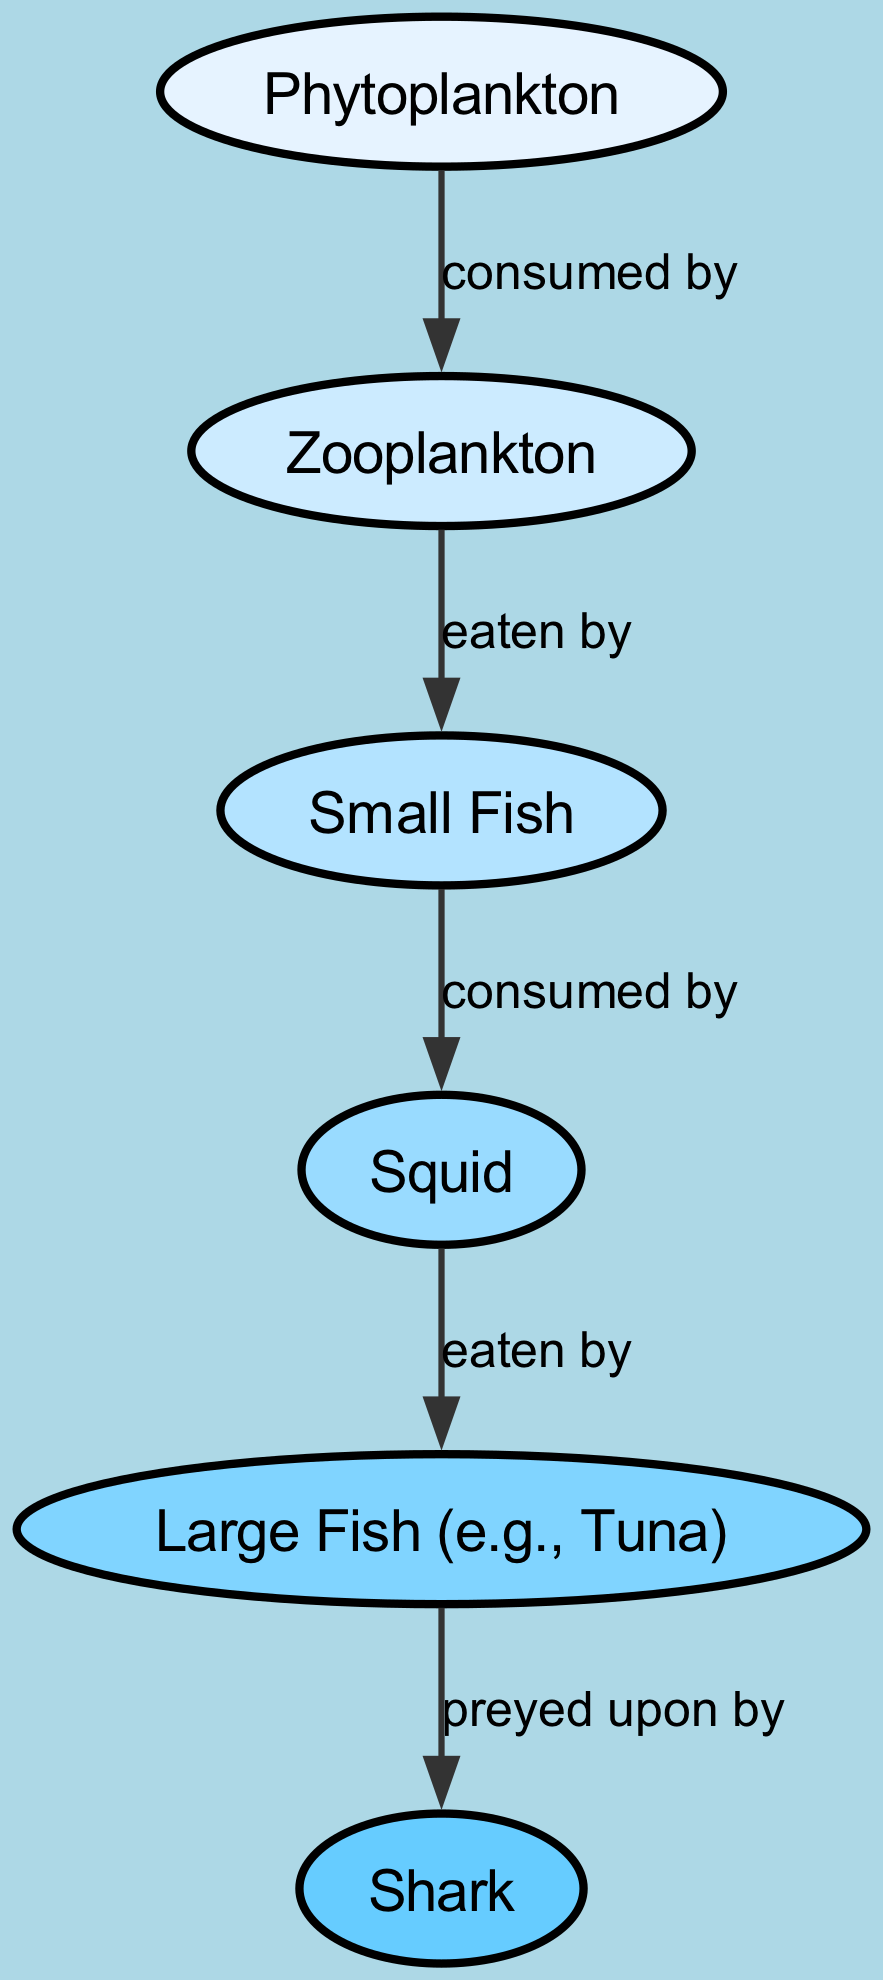What is the first node in the food chain? The first node in the food chain is indicated as the starting point where the energy flow begins. From the diagram, it shows that "Phytoplankton" is the initial node.
Answer: Phytoplankton How many nodes are present in the diagram? To find the total number of nodes, we can count each element listed under "nodes" in the data provided. There are six distinct elements in total: Phytoplankton, Zooplankton, Small Fish, Squid, Large Fish, and Shark.
Answer: 6 Which organism is directly consumed by Zooplankton? In the diagram, an arrow points from "Phytoplankton" to "Zooplankton" labeled "consumed by," indicating that Zooplankton consumes Phytoplankton.
Answer: Phytoplankton What is the last node that appears in the food chain? The last node in this food chain represents the apex predator within this ecosystem, and looking at the diagram, the final node shown is designated as "Shark."
Answer: Shark Which organisms does Small Fish consume? The diagram shows a directed edge from "Zooplankton" to "Small Fish" labeled "eaten by." This indicates that Small Fish is consumed by Zooplankton. No further organisms are shown as consumed by Small Fish.
Answer: Zooplankton Who preys upon Large Fish? According to the structure of the food chain depicted in the diagram, "Shark" is shown with an arrow pointing to "Large Fish," and the label indicates "preyed upon by." This clearly identifies Shark as the organism that preys on Large Fish.
Answer: Shark What is the total number of edges in the diagram? By examining the connections (edges) established between the various nodes, we can tally them up. There are five edges: from Phytoplankton to Zooplankton, Zooplankton to Small Fish, Small Fish to Squid, Squid to Large Fish, and Large Fish to Shark.
Answer: 5 What type of organism includes both Squid and Small Fish? To find the category these organisms fall under, we need to assess their role in the aquatic ecosystem. Both Squid and Small Fish can be identified as "predators" in the sense that they consume other organisms in the food chain.
Answer: Predators 